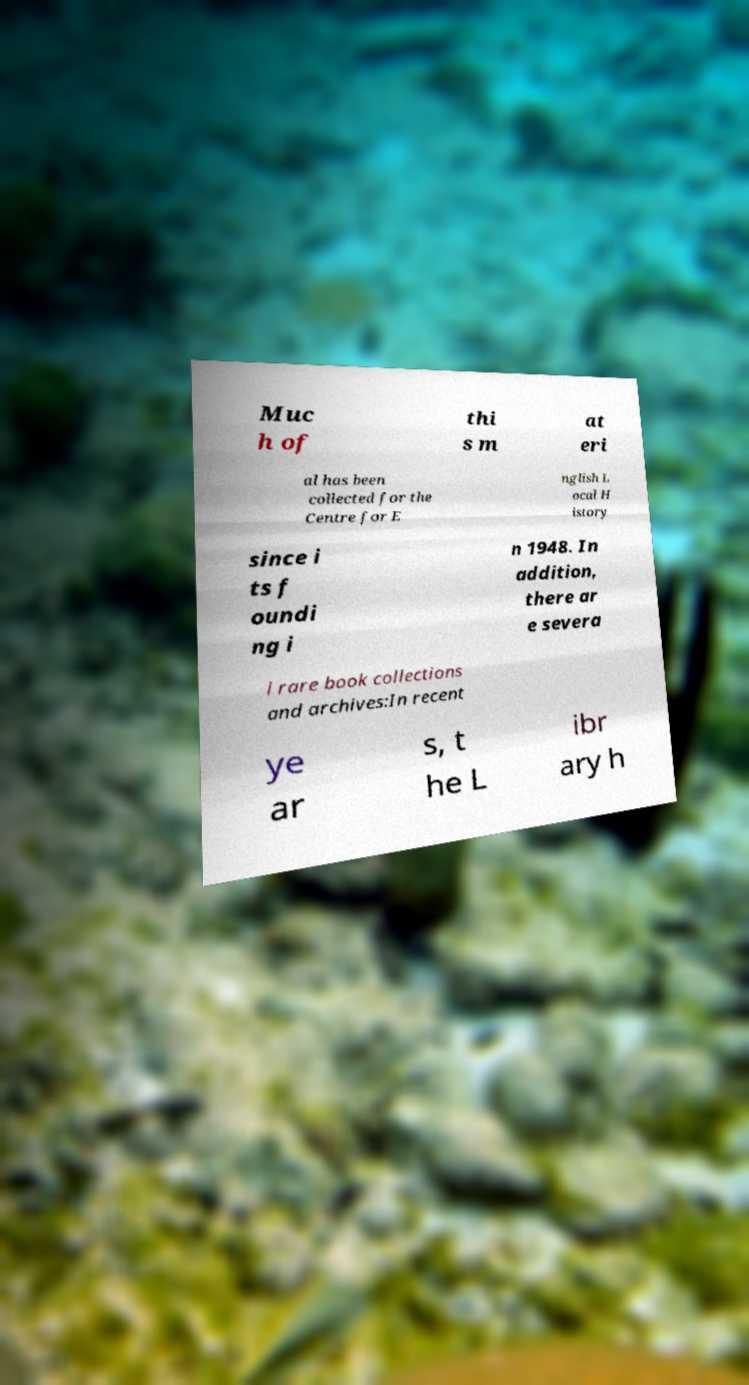For documentation purposes, I need the text within this image transcribed. Could you provide that? Muc h of thi s m at eri al has been collected for the Centre for E nglish L ocal H istory since i ts f oundi ng i n 1948. In addition, there ar e severa l rare book collections and archives:In recent ye ar s, t he L ibr ary h 